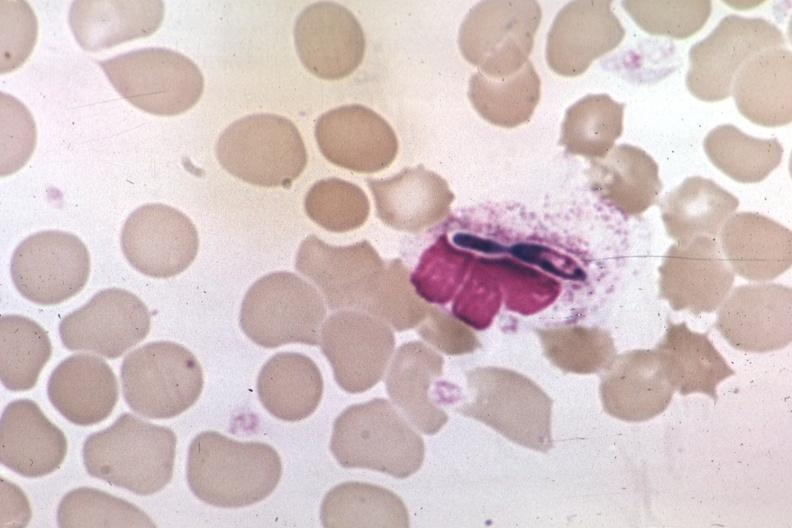s hematologic present?
Answer the question using a single word or phrase. Yes 